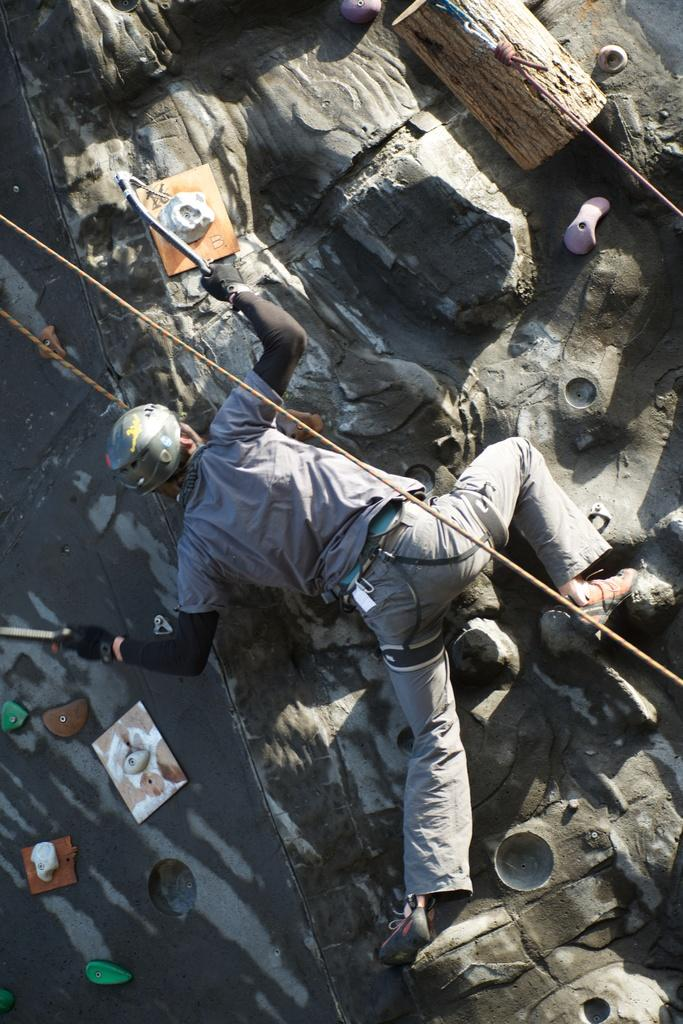What is happening in the image? There is a person in the image, and the person is climbing. Can you describe the person's activity in more detail? The person is engaged in the act of climbing, which typically involves ascending a surface or structure. How many jars are being exchanged between the climber and the person at the top of the structure? There is no mention of jars or an exchange in the image, as the focus is solely on the person climbing. 